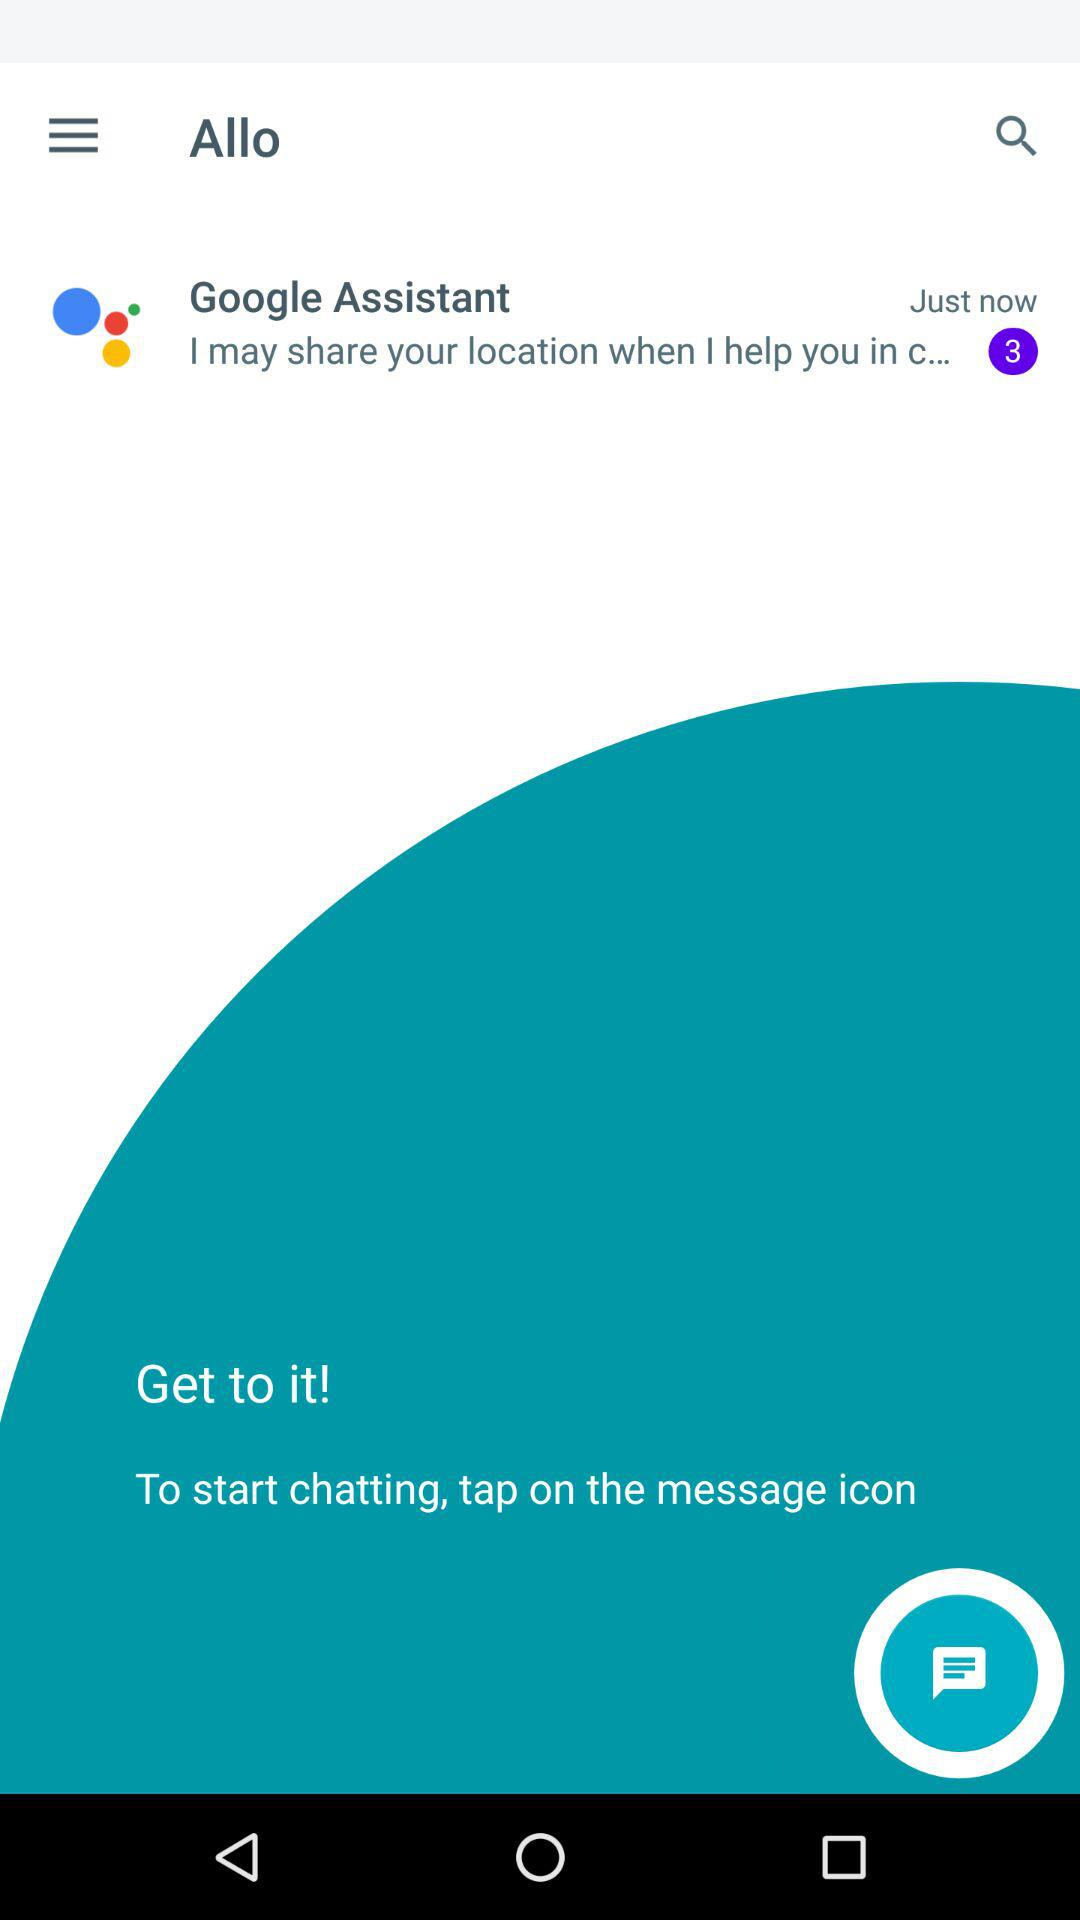How do you invite someone to the chat?
When the provided information is insufficient, respond with <no answer>. <no answer> 